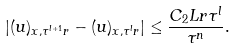<formula> <loc_0><loc_0><loc_500><loc_500>| ( u ) _ { x , \tau ^ { l + 1 } r } - ( u ) _ { x , \tau ^ { l } r } | \leq \frac { C _ { 2 } L r \tau ^ { l } } { \tau ^ { n } } .</formula> 